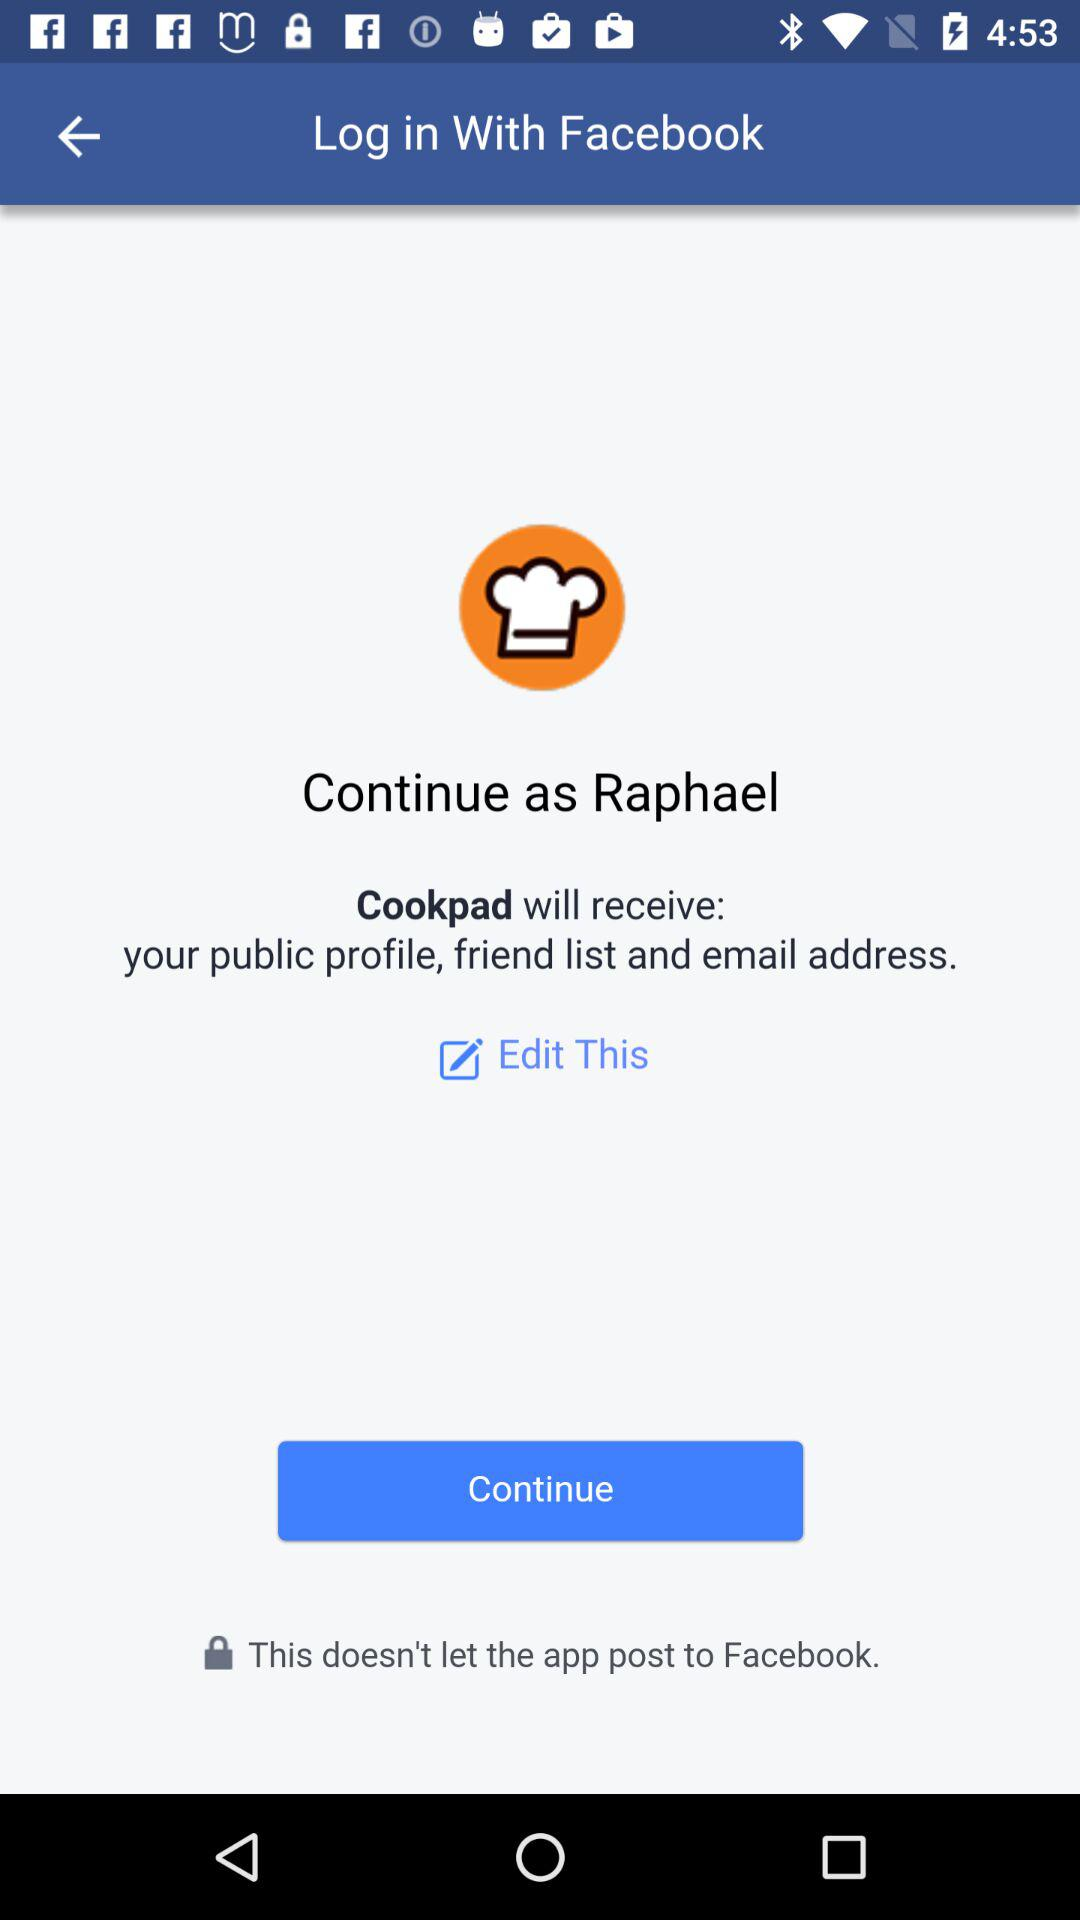What application is asking for permission? The application that is asking for permission is "Cookpad". 